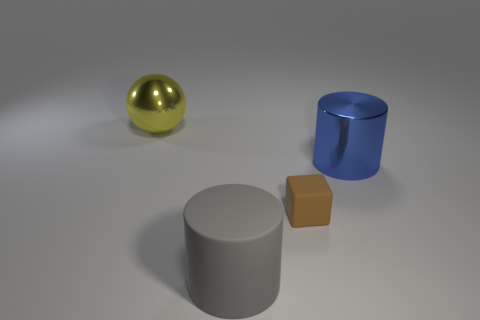Add 2 brown matte things. How many objects exist? 6 Subtract all spheres. How many objects are left? 3 Add 1 large red rubber things. How many large red rubber things exist? 1 Subtract 0 blue cubes. How many objects are left? 4 Subtract all small brown metal objects. Subtract all gray cylinders. How many objects are left? 3 Add 1 small brown matte blocks. How many small brown matte blocks are left? 2 